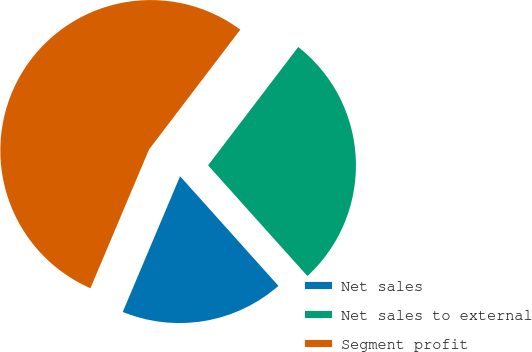Convert chart. <chart><loc_0><loc_0><loc_500><loc_500><pie_chart><fcel>Net sales<fcel>Net sales to external<fcel>Segment profit<nl><fcel>18.0%<fcel>28.0%<fcel>54.0%<nl></chart> 